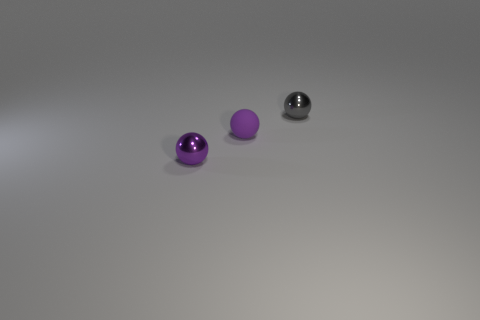There is a tiny purple metal thing in front of the matte object; does it have the same shape as the metal thing that is behind the tiny matte thing?
Your response must be concise. Yes. What number of other objects are there of the same material as the gray thing?
Your response must be concise. 1. There is a small purple object that is the same material as the tiny gray ball; what shape is it?
Provide a succinct answer. Sphere. Is the purple matte thing the same size as the purple shiny ball?
Your response must be concise. Yes. There is a metallic object that is to the left of the shiny ball that is to the right of the small matte thing; how big is it?
Provide a succinct answer. Small. There is a metallic object that is the same color as the tiny rubber ball; what shape is it?
Your answer should be very brief. Sphere. How many spheres are either tiny green objects or shiny objects?
Offer a terse response. 2. Are there more tiny metallic objects that are right of the small rubber sphere than tiny balls?
Your answer should be very brief. No. What is the size of the purple thing that is made of the same material as the gray ball?
Give a very brief answer. Small. Is there a tiny metallic sphere that has the same color as the tiny matte sphere?
Offer a very short reply. Yes. 